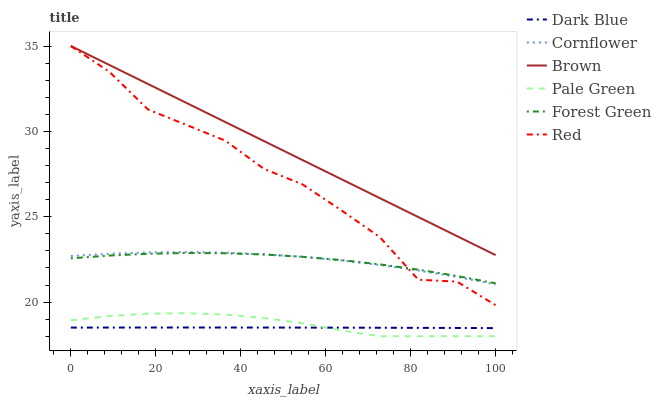Does Dark Blue have the minimum area under the curve?
Answer yes or no. Yes. Does Brown have the maximum area under the curve?
Answer yes or no. Yes. Does Cornflower have the minimum area under the curve?
Answer yes or no. No. Does Cornflower have the maximum area under the curve?
Answer yes or no. No. Is Brown the smoothest?
Answer yes or no. Yes. Is Red the roughest?
Answer yes or no. Yes. Is Cornflower the smoothest?
Answer yes or no. No. Is Cornflower the roughest?
Answer yes or no. No. Does Pale Green have the lowest value?
Answer yes or no. Yes. Does Cornflower have the lowest value?
Answer yes or no. No. Does Red have the highest value?
Answer yes or no. Yes. Does Cornflower have the highest value?
Answer yes or no. No. Is Dark Blue less than Cornflower?
Answer yes or no. Yes. Is Forest Green greater than Pale Green?
Answer yes or no. Yes. Does Cornflower intersect Red?
Answer yes or no. Yes. Is Cornflower less than Red?
Answer yes or no. No. Is Cornflower greater than Red?
Answer yes or no. No. Does Dark Blue intersect Cornflower?
Answer yes or no. No. 